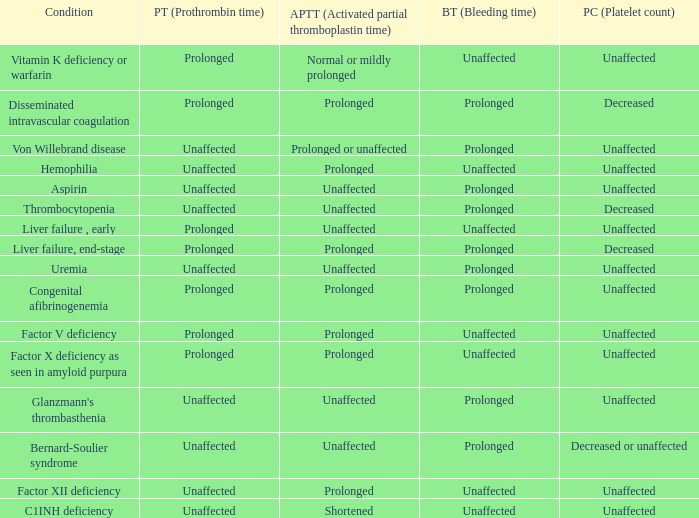What is hemophilia's bleeding time? Unaffected. 